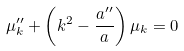<formula> <loc_0><loc_0><loc_500><loc_500>\mu ^ { \prime \prime } _ { k } + \left ( k ^ { 2 } - \frac { a ^ { \prime \prime } } { a } \right ) \mu _ { k } = 0</formula> 